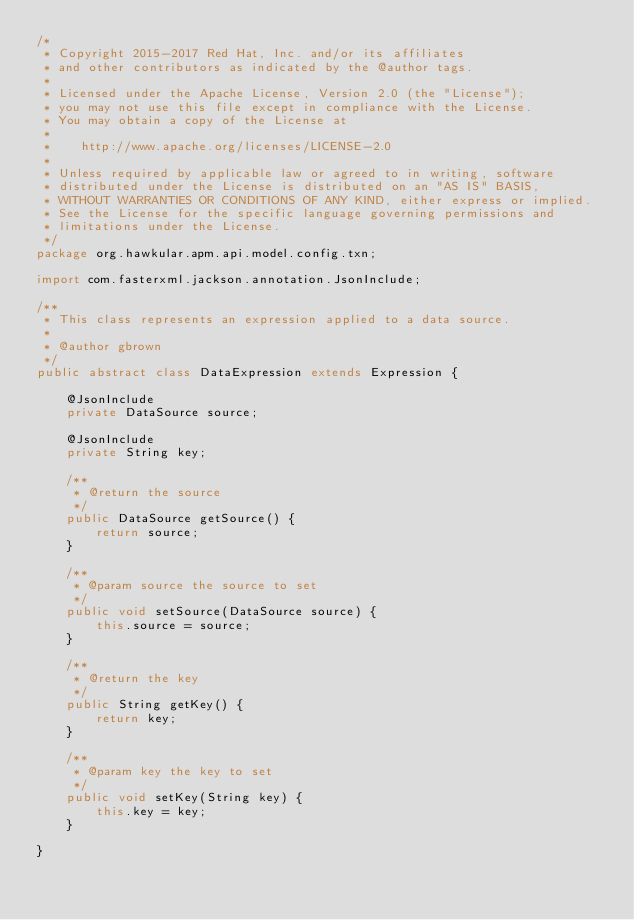Convert code to text. <code><loc_0><loc_0><loc_500><loc_500><_Java_>/*
 * Copyright 2015-2017 Red Hat, Inc. and/or its affiliates
 * and other contributors as indicated by the @author tags.
 *
 * Licensed under the Apache License, Version 2.0 (the "License");
 * you may not use this file except in compliance with the License.
 * You may obtain a copy of the License at
 *
 *    http://www.apache.org/licenses/LICENSE-2.0
 *
 * Unless required by applicable law or agreed to in writing, software
 * distributed under the License is distributed on an "AS IS" BASIS,
 * WITHOUT WARRANTIES OR CONDITIONS OF ANY KIND, either express or implied.
 * See the License for the specific language governing permissions and
 * limitations under the License.
 */
package org.hawkular.apm.api.model.config.txn;

import com.fasterxml.jackson.annotation.JsonInclude;

/**
 * This class represents an expression applied to a data source.
 *
 * @author gbrown
 */
public abstract class DataExpression extends Expression {

    @JsonInclude
    private DataSource source;

    @JsonInclude
    private String key;

    /**
     * @return the source
     */
    public DataSource getSource() {
        return source;
    }

    /**
     * @param source the source to set
     */
    public void setSource(DataSource source) {
        this.source = source;
    }

    /**
     * @return the key
     */
    public String getKey() {
        return key;
    }

    /**
     * @param key the key to set
     */
    public void setKey(String key) {
        this.key = key;
    }

}
</code> 